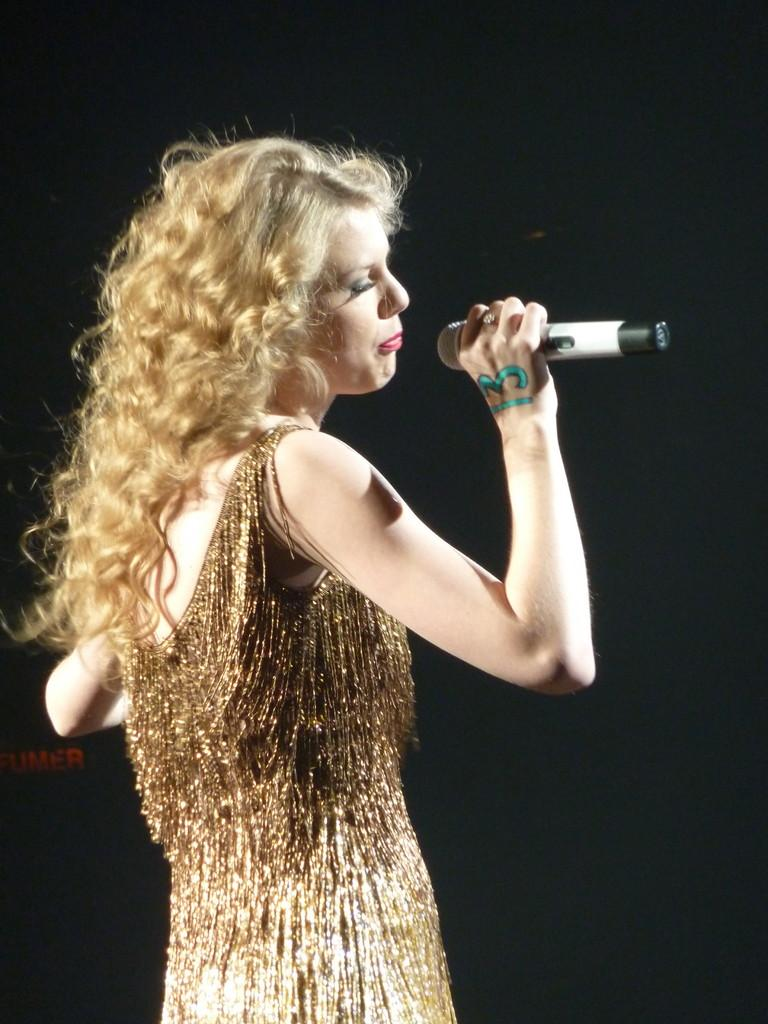Who is the main subject in the image? There is a woman in the image. What is the woman holding in her hand? The woman is holding a mic in her hand. What is the woman doing in the image? The woman is singing. What color is the dress the woman is wearing? The woman is wearing a golden color dress. How does the woman maintain her balance while singing and holding the mic during her journey? There is no mention of a journey in the image, and the woman's balance is not a relevant detail in the provided facts. 